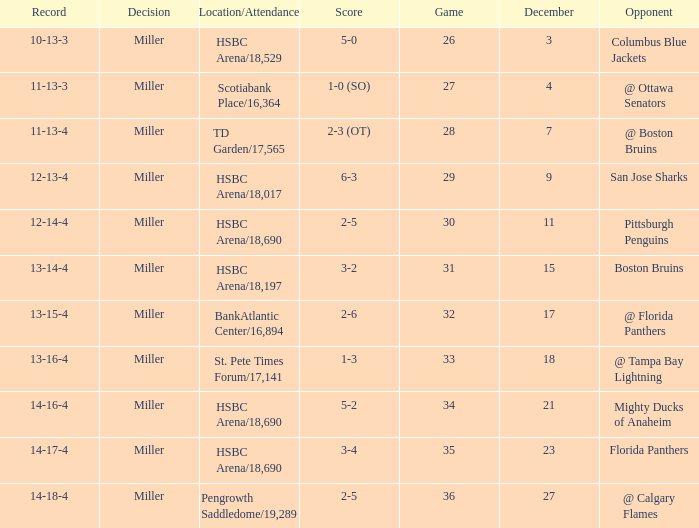Name the score for 29 game 6-3. 